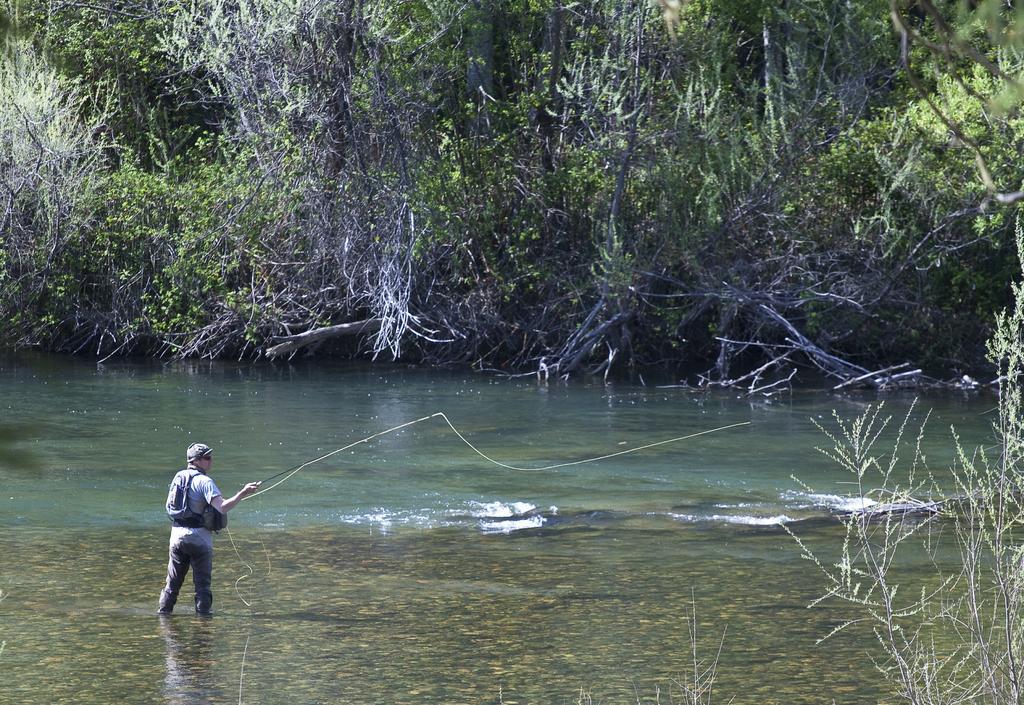Please provide a concise description of this image. In this image there is a man standing in the water by wearing the bag and holding the fishing stick. In the background there are so many trees. At the bottom there is water. There is a net to the stick. 